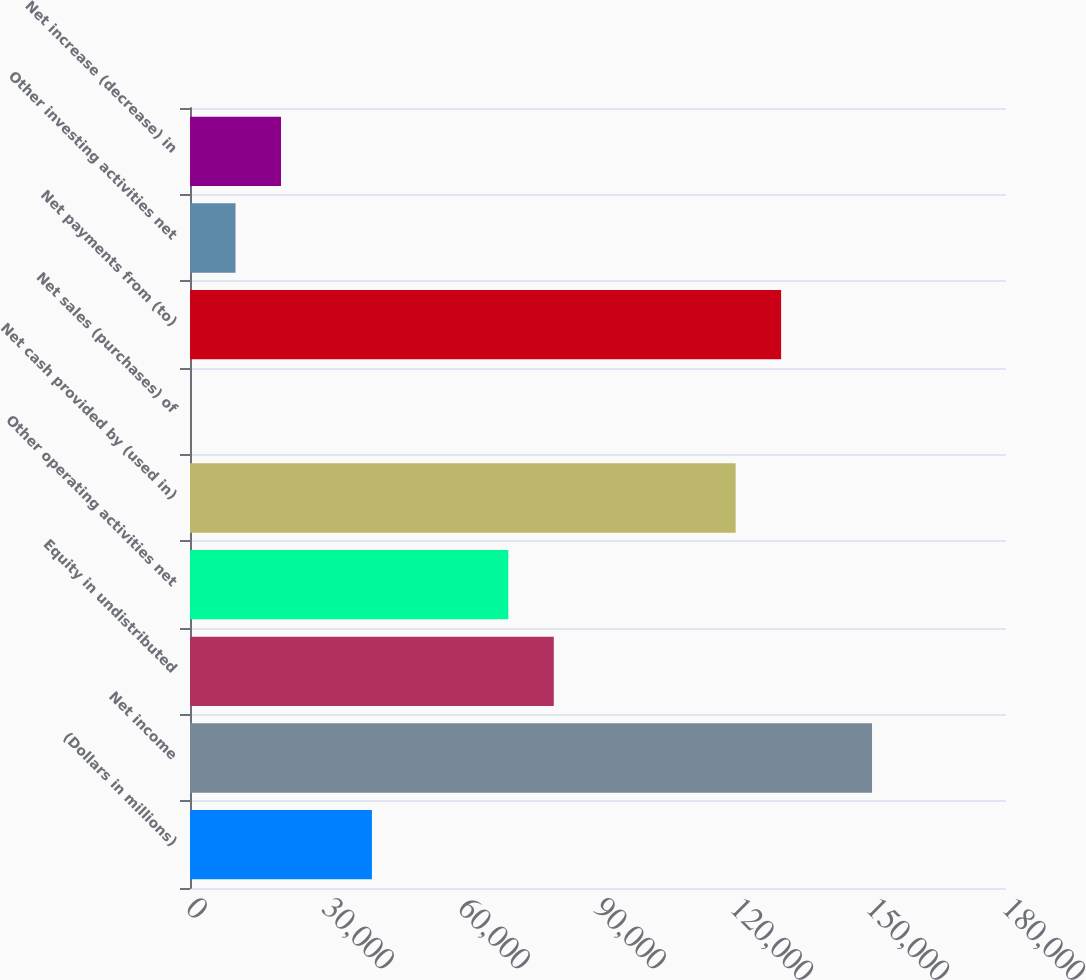<chart> <loc_0><loc_0><loc_500><loc_500><bar_chart><fcel>(Dollars in millions)<fcel>Net income<fcel>Equity in undistributed<fcel>Other operating activities net<fcel>Net cash provided by (used in)<fcel>Net sales (purchases) of<fcel>Net payments from (to)<fcel>Other investing activities net<fcel>Net increase (decrease) in<nl><fcel>40130.6<fcel>150448<fcel>80246.2<fcel>70217.3<fcel>120362<fcel>15<fcel>130391<fcel>10043.9<fcel>20072.8<nl></chart> 